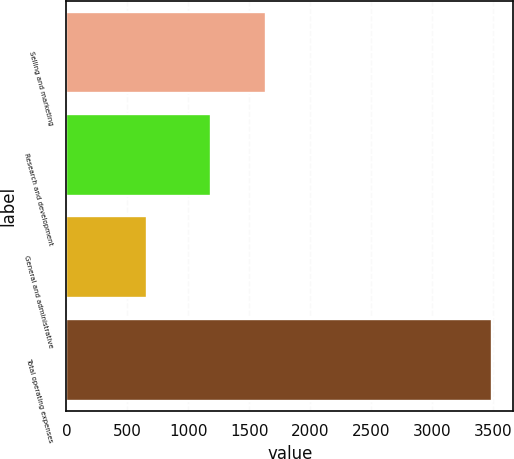<chart> <loc_0><loc_0><loc_500><loc_500><bar_chart><fcel>Selling and marketing<fcel>Research and development<fcel>General and administrative<fcel>Total operating expenses<nl><fcel>1634<fcel>1186<fcel>664<fcel>3490<nl></chart> 